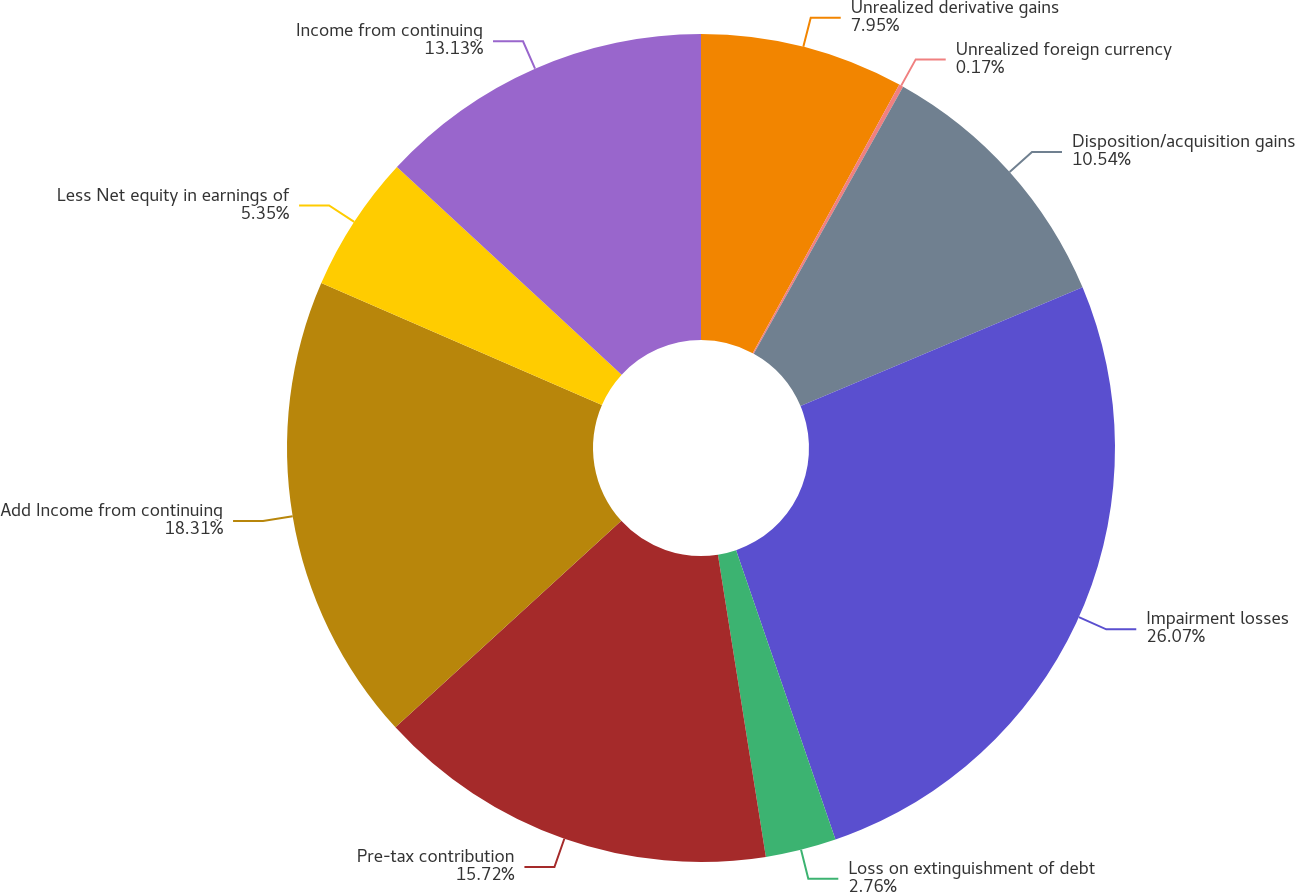<chart> <loc_0><loc_0><loc_500><loc_500><pie_chart><fcel>Unrealized derivative gains<fcel>Unrealized foreign currency<fcel>Disposition/acquisition gains<fcel>Impairment losses<fcel>Loss on extinguishment of debt<fcel>Pre-tax contribution<fcel>Add Income from continuing<fcel>Less Net equity in earnings of<fcel>Income from continuing<nl><fcel>7.95%<fcel>0.17%<fcel>10.54%<fcel>26.08%<fcel>2.76%<fcel>15.72%<fcel>18.31%<fcel>5.35%<fcel>13.13%<nl></chart> 